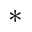Convert formula to latex. <formula><loc_0><loc_0><loc_500><loc_500>\ast</formula> 